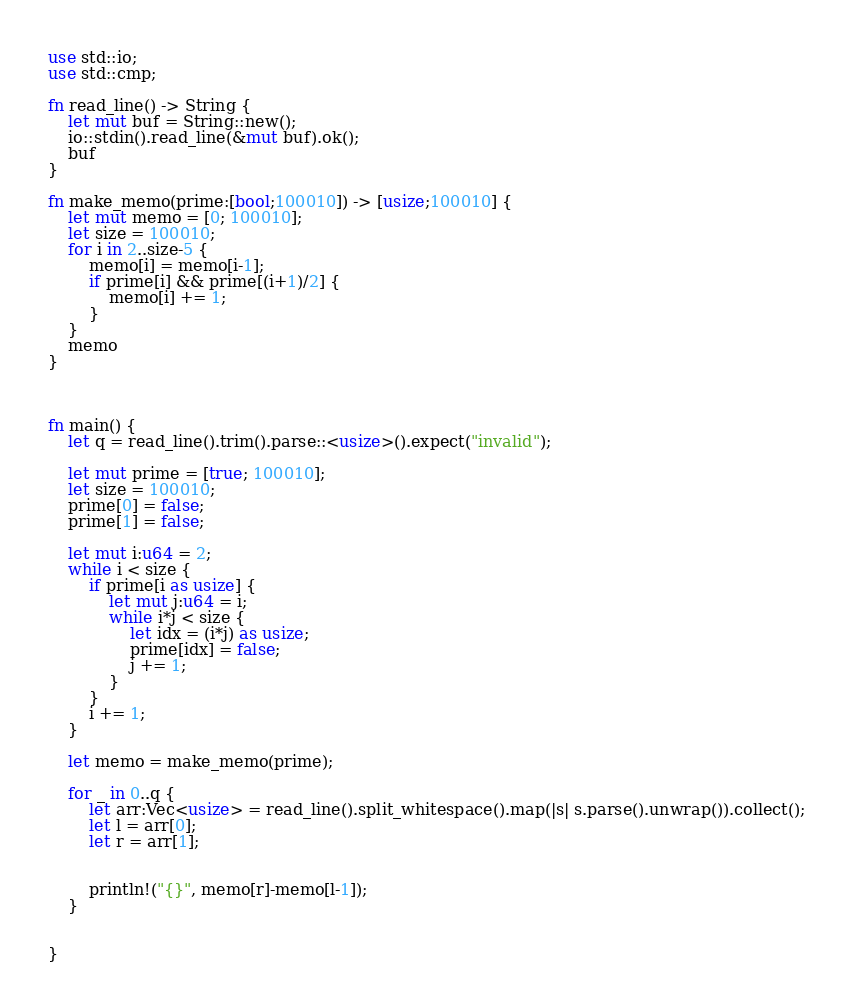<code> <loc_0><loc_0><loc_500><loc_500><_Rust_>use std::io;
use std::cmp;

fn read_line() -> String {
    let mut buf = String::new();
    io::stdin().read_line(&mut buf).ok();
    buf
}

fn make_memo(prime:[bool;100010]) -> [usize;100010] {
    let mut memo = [0; 100010];
    let size = 100010;
    for i in 2..size-5 {
        memo[i] = memo[i-1];
        if prime[i] && prime[(i+1)/2] {
            memo[i] += 1;
        }
    }
    memo
}



fn main() {
    let q = read_line().trim().parse::<usize>().expect("invalid");

    let mut prime = [true; 100010];
    let size = 100010;
    prime[0] = false;
    prime[1] = false;

    let mut i:u64 = 2;
    while i < size {
        if prime[i as usize] {
            let mut j:u64 = i;
            while i*j < size {
                let idx = (i*j) as usize;
                prime[idx] = false;
                j += 1;
            }
        }
        i += 1;
    }

    let memo = make_memo(prime);

    for _ in 0..q {
        let arr:Vec<usize> = read_line().split_whitespace().map(|s| s.parse().unwrap()).collect();
        let l = arr[0];
        let r = arr[1];


        println!("{}", memo[r]-memo[l-1]);
    }


}
</code> 